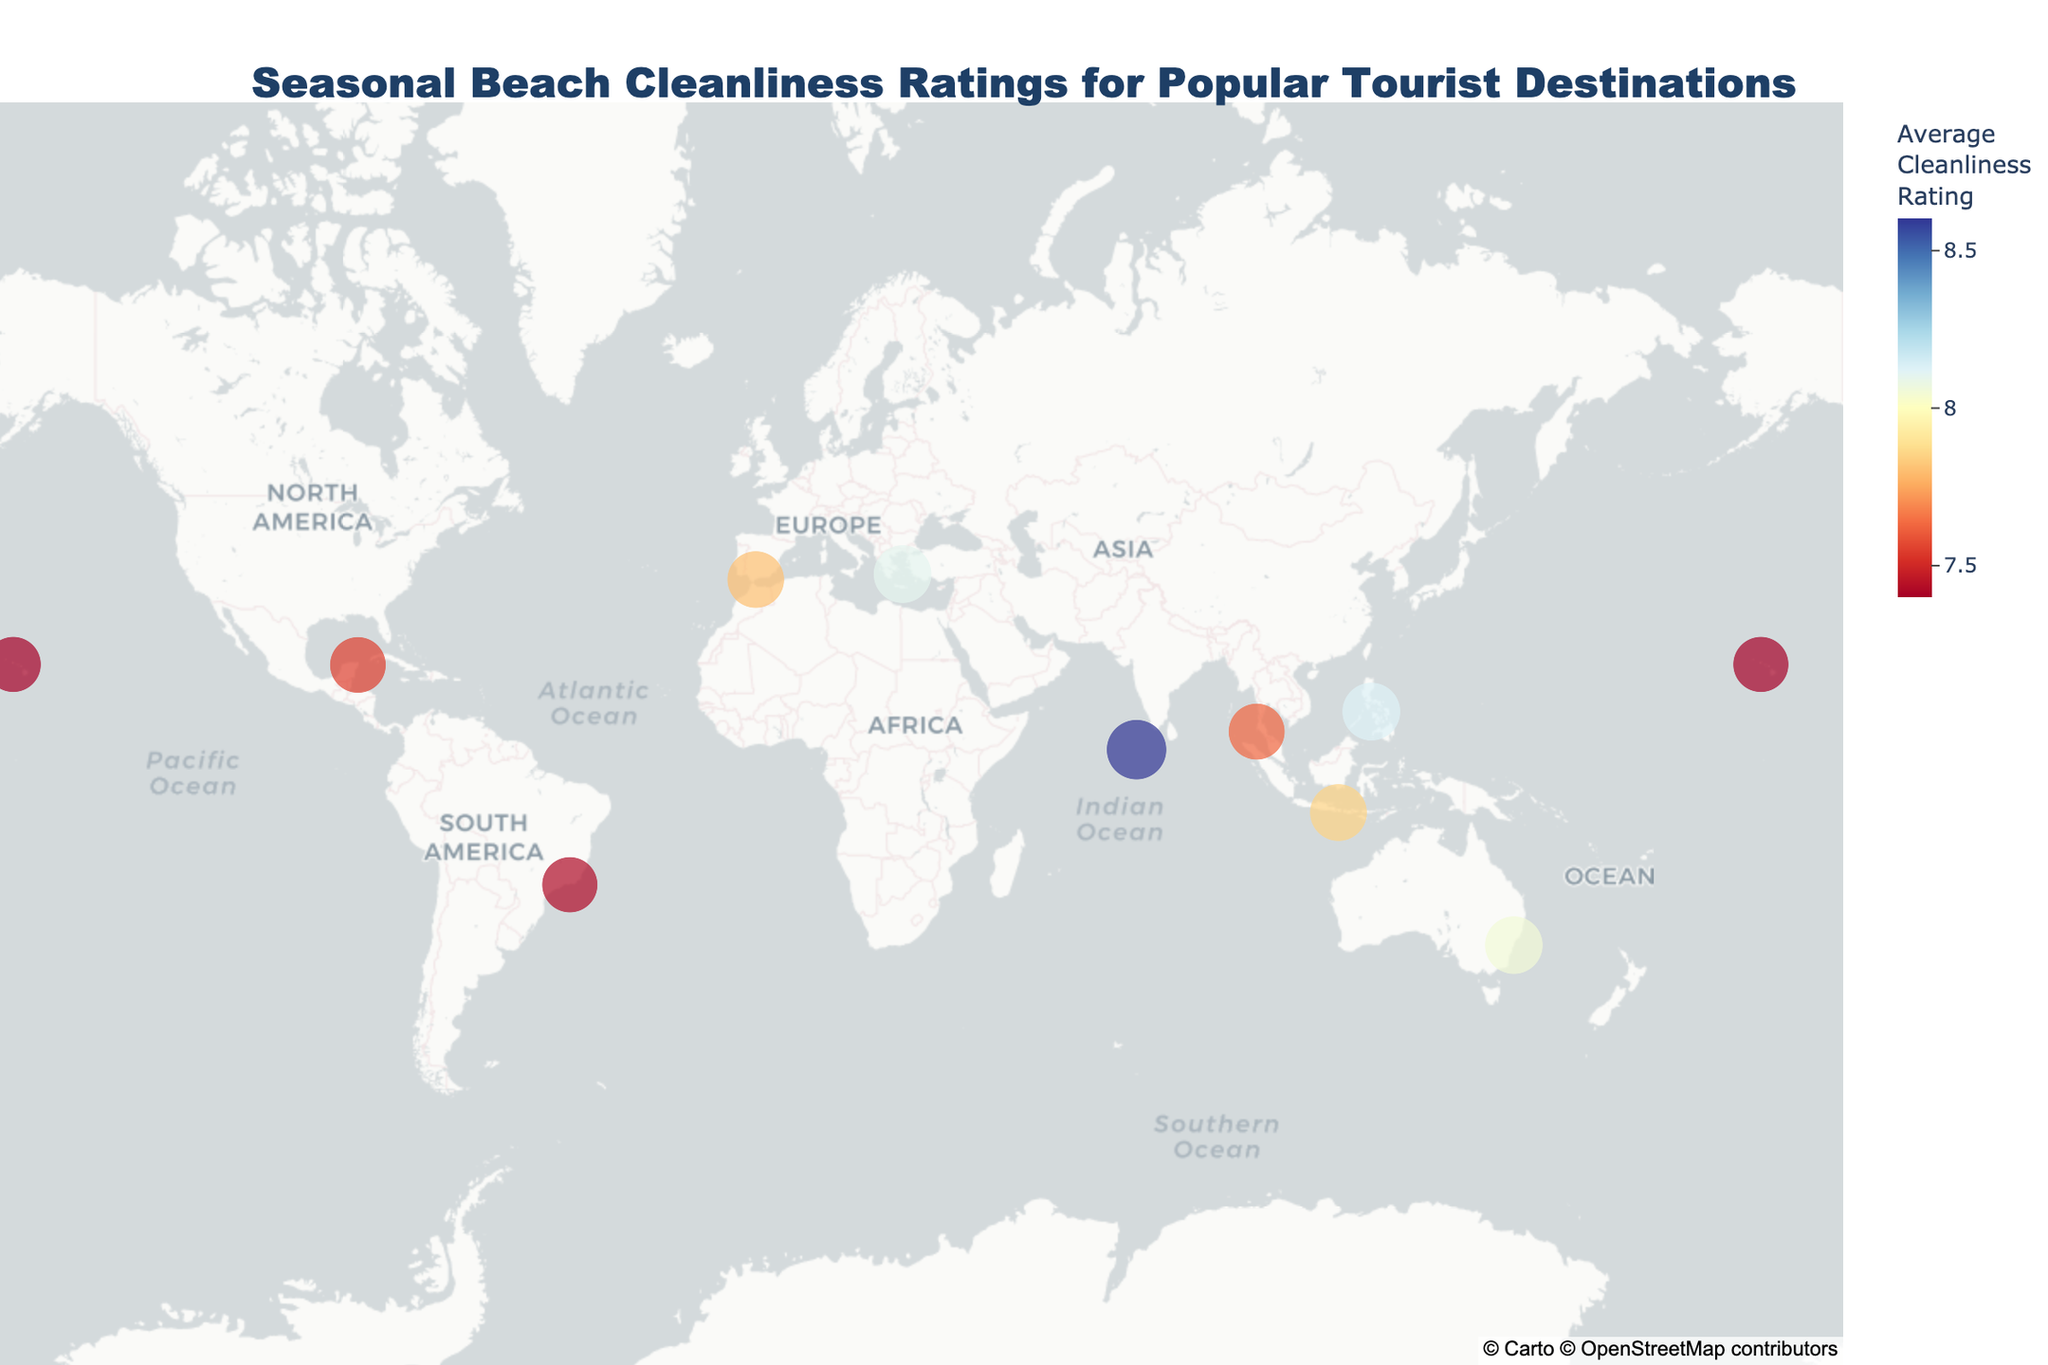Which beach destination has the highest average cleanliness rating? To determine which beach destination has the highest average cleanliness rating, look at the size and color intensity of the data points on the map. The Maldives Hulhumale Beach has the largest point and the most intense color, which indicates the highest average cleanliness rating.
Answer: Maldives Hulhumale Beach What is the cleanliness rating for Waikiki Beach in summer? To find the cleanliness rating for Waikiki Beach in the summer, hover over the data point corresponding to Waikiki Beach Hawaii and check the summer cleanliness rating displayed in the hover information.
Answer: 6.5 Which season generally shows the highest cleanliness ratings across most destinations? To identify the season with the highest cleanliness ratings, compare the seasonal ratings for each destination in the hover information. Winter seems to have the highest ratings as it appears frequently with values above 8.0 across multiple destinations.
Answer: Winter How does the average cleanliness rating of Copacabana Beach compare to that of Bondi Beach? To compare the average cleanliness ratings, look at the values in the hover information for each destination. Copacabana Beach has an average rating lower than Bondi Beach. Specifically, Copacabana averages around 7.42, whereas Bondi Beach averages around 8.05.
Answer: Bondi Beach has a higher rating What is the approximate latitude and longitude of Mykonos Paradise Beach? To determine the latitude and longitude of Mykonos Paradise Beach, hover over the respective data point on the map to see the geographic coordinates.
Answer: Roughly 37.4132, 25.3491 Is there any beach with an average cleanliness rating above 8.5? To identify if any beach has an average cleanliness rating above 8.5, look for the most intense color data points and check the hover details for the ratings. Maldives Hulhumale Beach meets this criterion with an average above 8.5.
Answer: Yes, Maldives Hulhumale Beach Which beach shows the largest seasonal variation in cleanliness ratings? To find the beach with the largest seasonal variation, compare the range of cleanliness ratings across seasons for each destination in the hover information. Phuket Patong Beach in Thailand has noticeable variation, particularly between summer (6.7) and winter (8.6).
Answer: Phuket Patong Beach What is the difference in cleanliness ratings between spring and winter for Bondi Beach? To find the difference in cleanliness ratings between spring and winter for Bondi Beach, look at the hover data for Bondi Beach and subtract the spring rating (8.2) from the winter rating (7.6). The difference is 0.6.
Answer: 0.6 Which beach has the lowest cleanliness rating during the summer? To find the beach with the lowest cleanliness rating in the summer, look for the beach with the smallest value in the summer column in the hover information. Waikiki Beach Hawaii has the lowest summer rating of 6.5 which is relatively low compared to others.
Answer: Waikiki Beach Hawaii How many beach destinations are plotted on the map? To determine the number of beach destinations on the map, count the total data points displayed on the map. There are 10 data points representing 10 beach destinations.
Answer: 10 